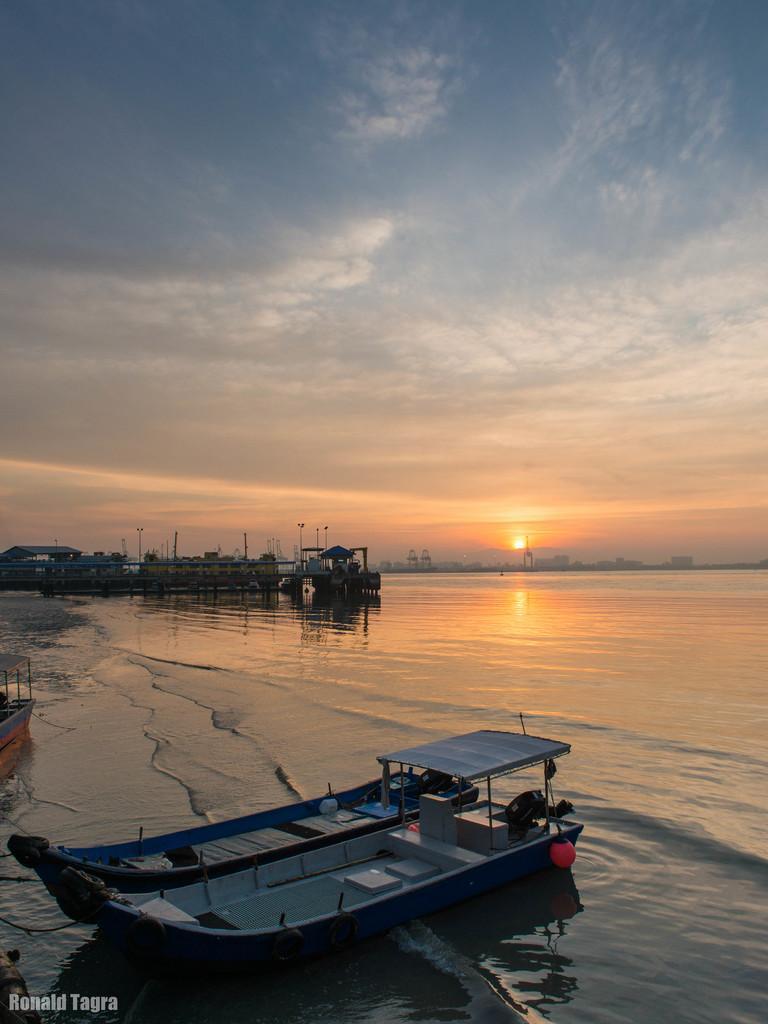Describe this image in one or two sentences. In this image we can see boats, water, sunrise and cloudy sky. Far there is a shed and poles. 